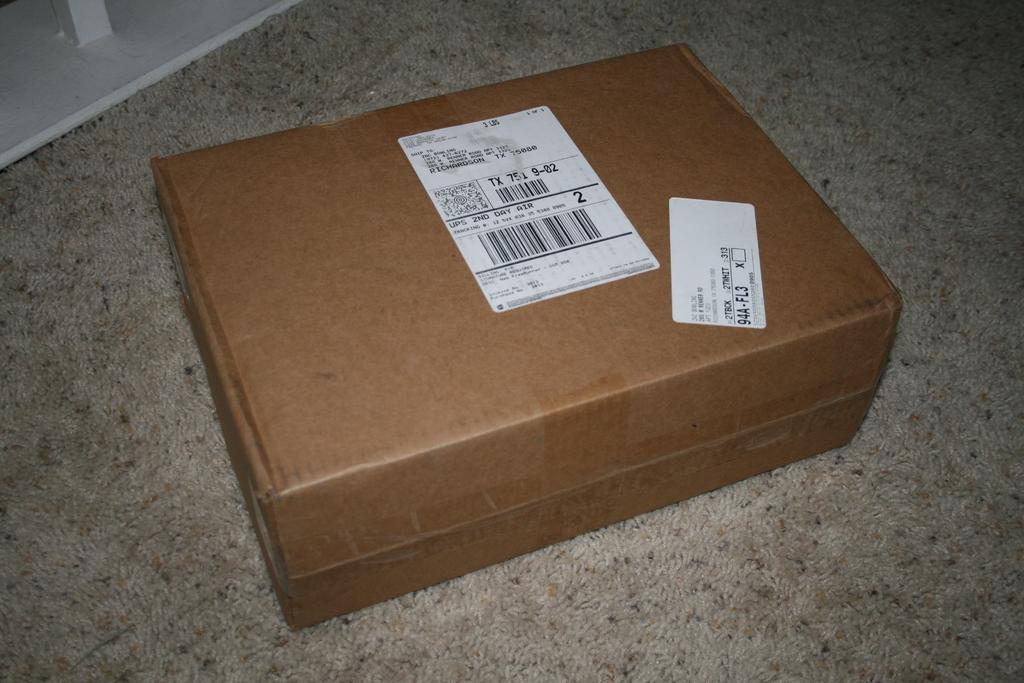Provide a one-sentence caption for the provided image. A package that is addressed to Zac Bowlling. 